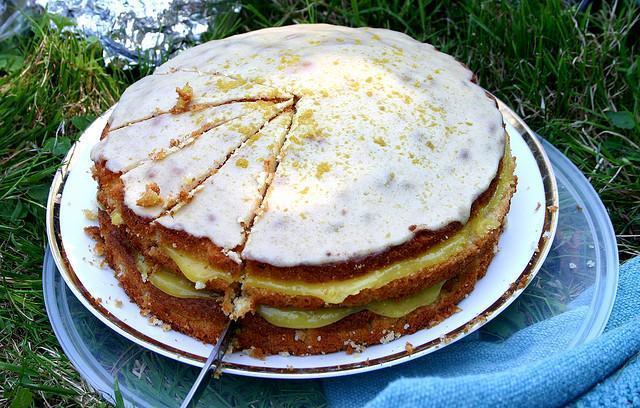How many large bags is the old man holding?
Give a very brief answer. 0. 